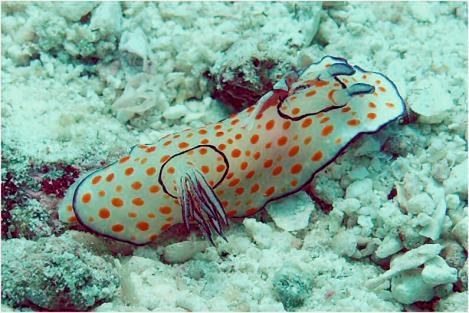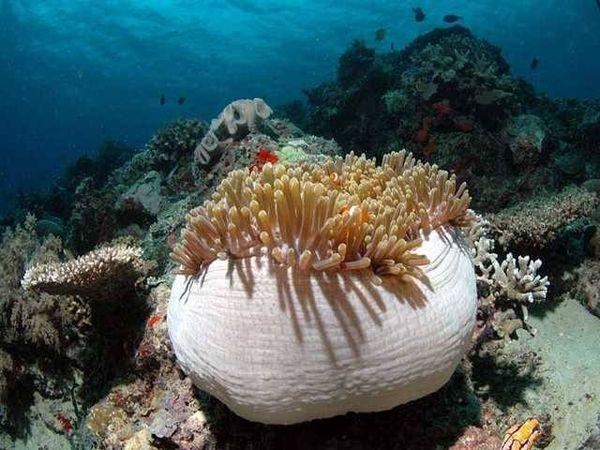The first image is the image on the left, the second image is the image on the right. Analyze the images presented: Is the assertion "there are black fish with a white spot swimming around the reef" valid? Answer yes or no. No. 